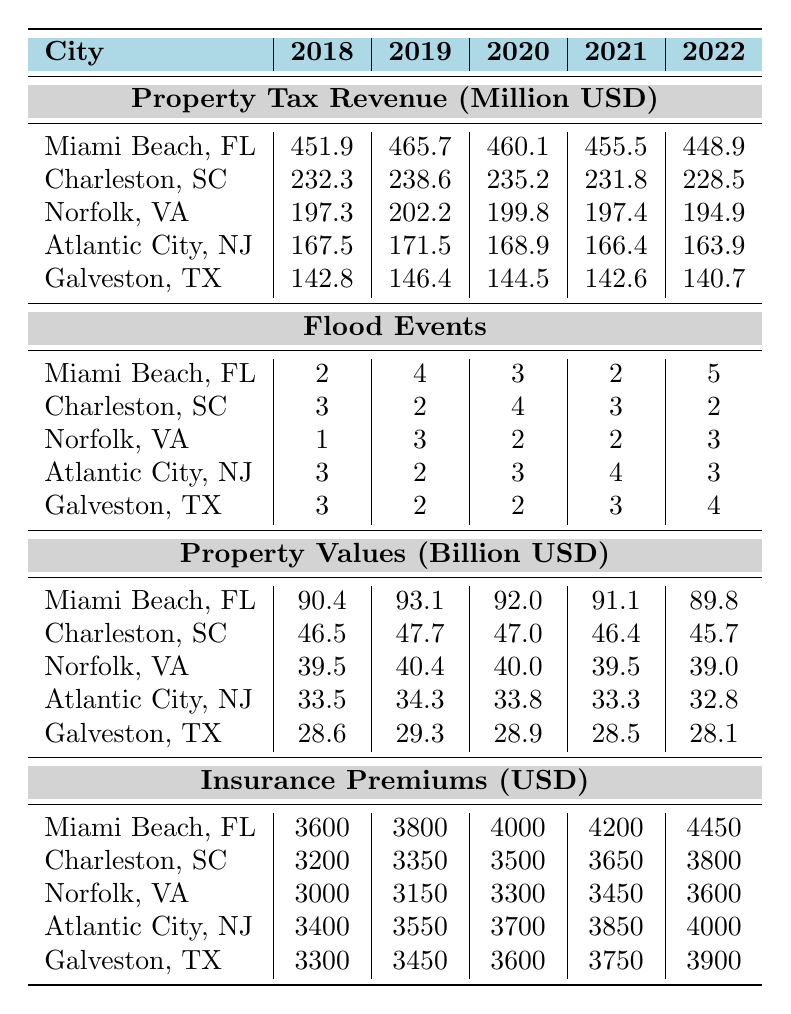What was the property tax revenue for Miami Beach, FL in 2021? The table shows that the property tax revenue for Miami Beach, FL in 2021 is 455.5 million USD.
Answer: 455.5 million USD Which city had the highest property tax revenue in 2019? The table indicates that Miami Beach, FL had the highest property tax revenue in 2019, at 465.7 million USD.
Answer: Miami Beach, FL How many flood events did Norfolk, VA experience in 2020? The data for Norfolk, VA in 2020 shows there were 2 flood events.
Answer: 2 flood events What is the average property tax revenue for Atlantic City, NJ over the years 2018 to 2022? Total property tax revenue for Atlantic City, NJ from 2018 to 2022 is 167.5 + 171.5 + 168.9 + 166.4 + 163.9 = 838.2 million USD. The average is 838.2 / 5 = 167.64 million USD.
Answer: 167.64 million USD Did Galveston, TX experience more flood events in 2021 than in 2019? In 2021, Galveston had 3 flood events, while in 2019 there were 2 events. Therefore, the statement is true.
Answer: Yes What is the total change in property tax revenue for Charleston, SC from 2018 to 2022? The property tax revenue change is 228.5 (2022) - 232.3 (2018) = -3.8 million USD. Therefore, the total change is a decrease of 3.8 million USD.
Answer: -3.8 million USD Which city had the lowest reduction in property tax revenue from 2018 to 2022? The property tax revenues for each city were calculated for 2018 and 2022: Charleston = -3.8, Norfolk = -2.4, Atlantic City = -3.6, Galveston = -2.1, Miami Beach = -3.0. Galveston had the lowest reduction at -2.1 million USD.
Answer: Galveston, TX What were the insurance premiums in Miami Beach, FL in 2022? According to the table, the insurance premiums in Miami Beach, FL in 2022 were 4450 USD.
Answer: 4450 USD If we compare the average property values for all cities in 2020, which city had the highest average? The property values in 2020 were analyzed: Miami Beach = 92.0, Charleston = 47.0, Norfolk = 40.0, Atlantic City = 33.8, Galveston = 28.9. Miami Beach had the highest value of 92.0 billion USD in 2020.
Answer: Miami Beach, FL By how much did the flood events in Miami Beach, FL increase from 2019 to 2022? The number of flood events for Miami Beach, FL: 2019 = 4 events, 2022 = 5 events. The increase is 5 - 4 = 1 event.
Answer: 1 event 